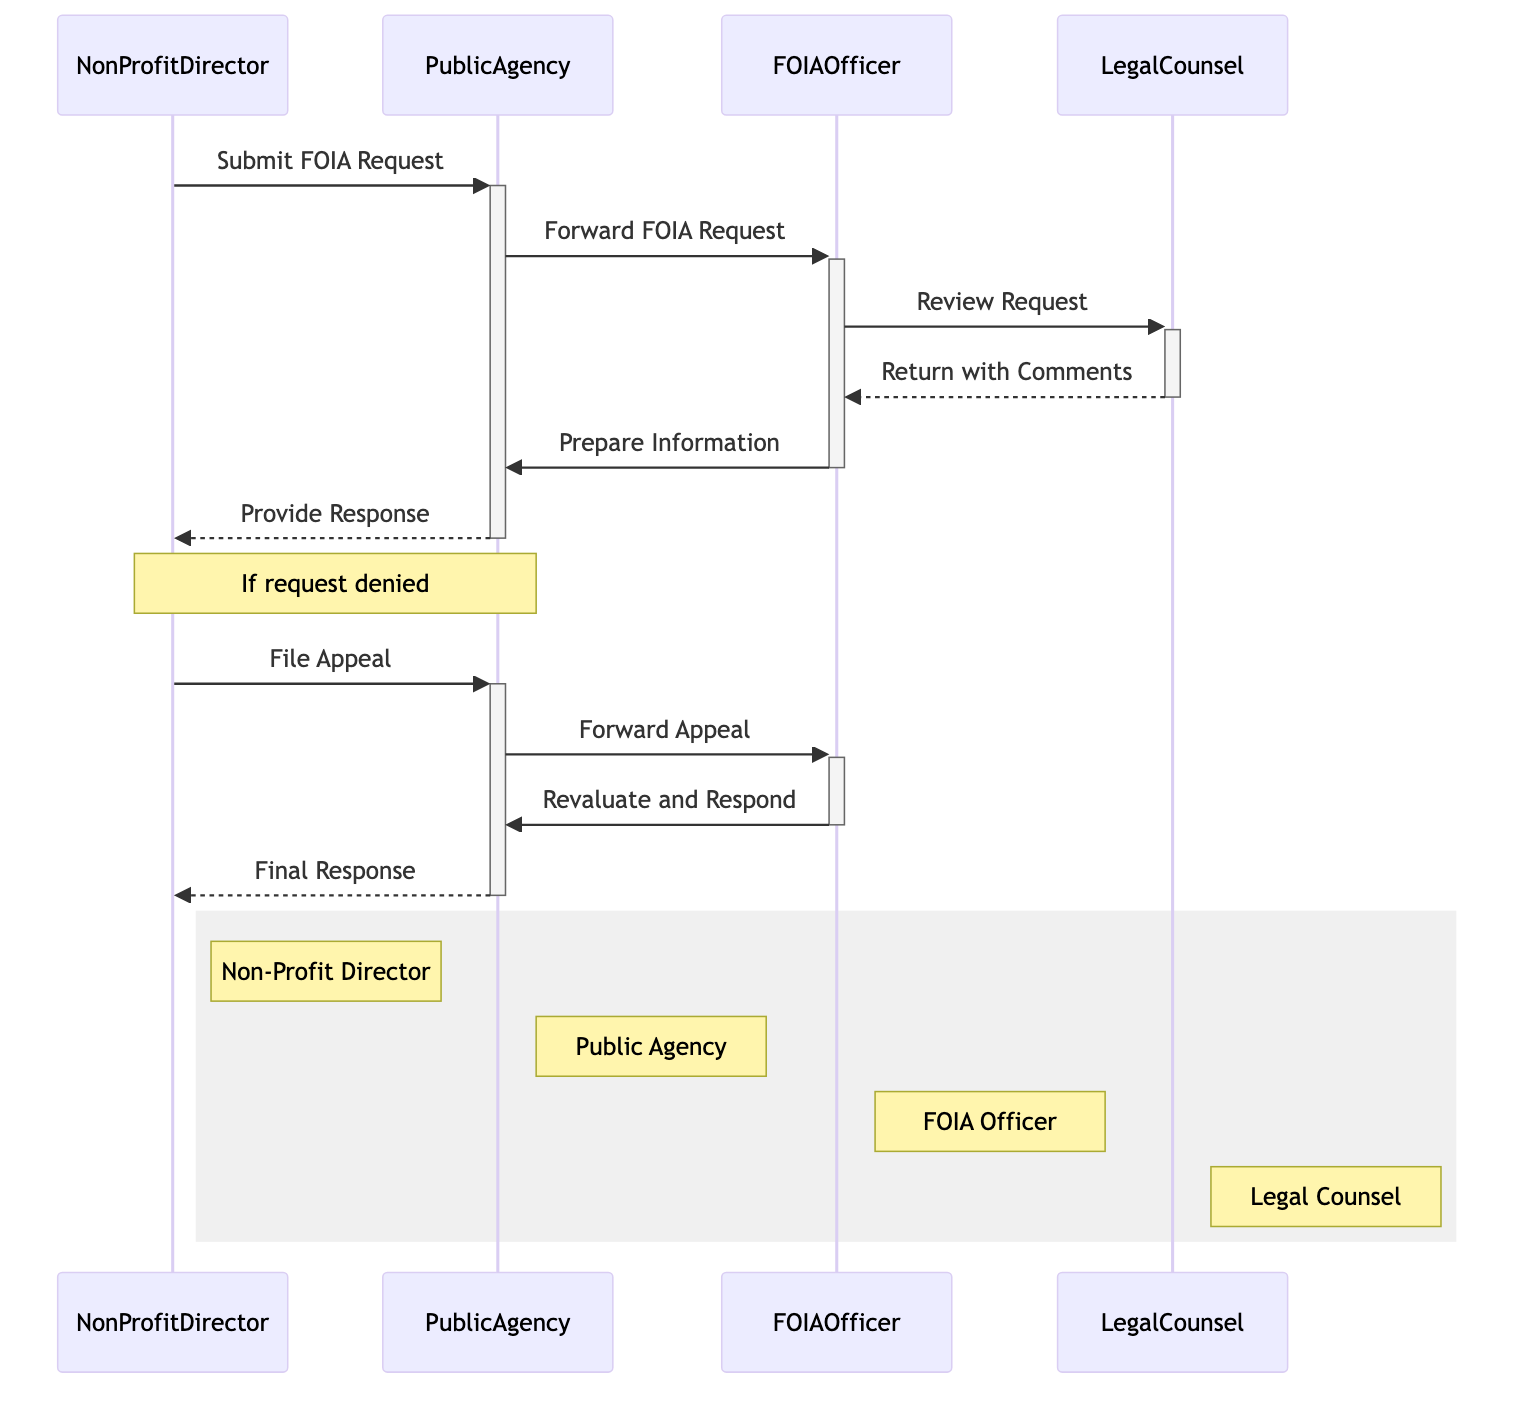What is the first action in the workflow? The first action in the workflow is initiated by the NonProfitDirector, who submits a FOIA Request to the PublicAgency.
Answer: Submit FOIA Request Who does the PublicAgency forward the FOIA request to? The PublicAgency forwards the FOIA request to the designated FOIAOfficer for processing.
Answer: FOIAOfficer How many total actors are there in the diagram? There are four actors involved in the FOIA request workflow as shown in the diagram.
Answer: Four What happens if the FOIA request is denied? If the FOIA request is denied, the NonProfitDirector can file an appeal against the decision, initiating another sequence in the workflow.
Answer: File Appeal Which actor prepares the information for disclosure? The FOIAOfficer is responsible for preparing the information that can be disclosed and excluding any exempt information indicated by legal counsel.
Answer: FOIAOfficer In which stage does LegalCounsel review the FOIA request? LegalCounsel reviews the FOIA request immediately after the FOIAOfficer forwards it for compliance and exemptions.
Answer: Review Request What is the final response provided to the NonProfitDirector? The final response is delivered by the PublicAgency after the FOIAOfficer reevaluates the appeal and coordinates with LegalCounsel if necessary.
Answer: Final Response What is the role of LegalCounsel in the workflow? The role of LegalCounsel is to review the FOIA requests for compliance and possible exemptions, providing feedback to the FOIAOfficer.
Answer: Review compliance and exemptions What occurs between the FOIAOfficer and PublicAgency after the comments return from LegalCounsel? After receiving comments from LegalCounsel, the FOIAOfficer prepares the information for disclosure and sends it to the PublicAgency.
Answer: Prepare Information 